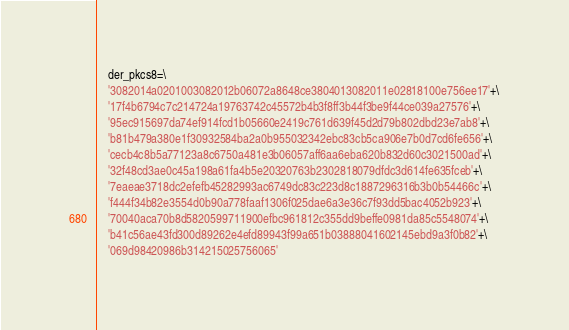Convert code to text. <code><loc_0><loc_0><loc_500><loc_500><_Python_>    der_pkcs8=\
    '3082014a0201003082012b06072a8648ce3804013082011e02818100e756ee17'+\
    '17f4b6794c7c214724a19763742c45572b4b3f8ff3b44f3be9f44ce039a27576'+\
    '95ec915697da74ef914fcd1b05660e2419c761d639f45d2d79b802dbd23e7ab8'+\
    'b81b479a380e1f30932584ba2a0b955032342ebc83cb5ca906e7b0d7cd6fe656'+\
    'cecb4c8b5a77123a8c6750a481e3b06057aff6aa6eba620b832d60c3021500ad'+\
    '32f48cd3ae0c45a198a61fa4b5e20320763b2302818079dfdc3d614fe635fceb'+\
    '7eaeae3718dc2efefb45282993ac6749dc83c223d8c1887296316b3b0b54466c'+\
    'f444f34b82e3554d0b90a778faaf1306f025dae6a3e36c7f93dd5bac4052b923'+\
    '70040aca70b8d5820599711900efbc961812c355dd9beffe0981da85c5548074'+\
    'b41c56ae43fd300d89262e4efd89943f99a651b03888041602145ebd9a3f0b82'+\
    '069d98420986b314215025756065'
</code> 